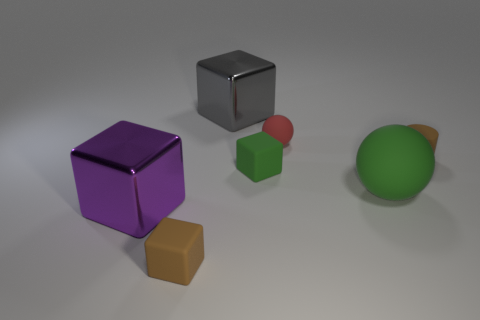There is a tiny rubber cylinder; is its color the same as the tiny rubber block that is behind the green matte sphere?
Ensure brevity in your answer.  No. There is a big rubber object that is the same shape as the tiny red object; what color is it?
Your answer should be compact. Green. Does the brown cylinder have the same material as the large block in front of the large ball?
Offer a terse response. No. The cylinder is what color?
Offer a very short reply. Brown. There is a big shiny object behind the cylinder behind the tiny cube right of the large gray block; what is its color?
Your answer should be very brief. Gray. Does the purple object have the same shape as the brown thing in front of the tiny brown rubber cylinder?
Ensure brevity in your answer.  Yes. What is the color of the big object that is in front of the green matte block and on the left side of the tiny sphere?
Offer a very short reply. Purple. Are there any other large green matte things that have the same shape as the big green thing?
Provide a succinct answer. No. Is the large matte object the same color as the tiny matte sphere?
Your answer should be compact. No. Is there a brown thing that is on the left side of the green object to the left of the big matte thing?
Provide a short and direct response. Yes. 